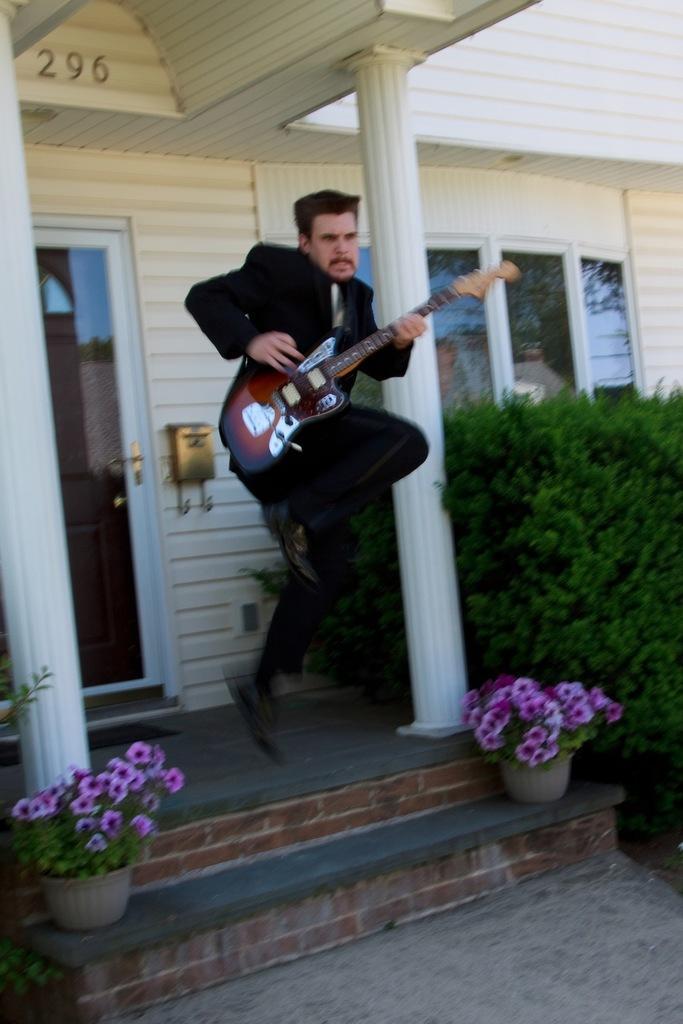In one or two sentences, can you explain what this image depicts? In this image i can see a person holding a guitar and wearing a black color suit an he is jumping in front a house and left side i can see a flower pot ,on the flowerpot there are some colorful flowers kept on that. on the right side i can see a another flower pot and there are some bushes and there is a window on the right side. 